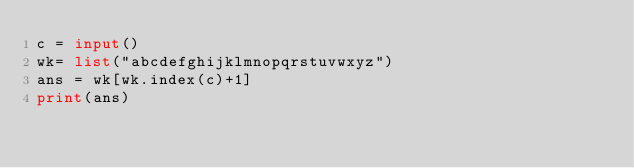<code> <loc_0><loc_0><loc_500><loc_500><_Python_>c = input()
wk= list("abcdefghijklmnopqrstuvwxyz")
ans = wk[wk.index(c)+1]
print(ans)</code> 